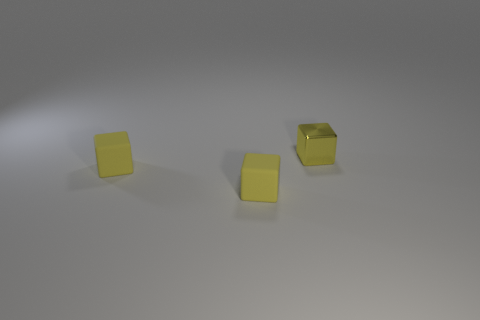Add 3 small yellow rubber things. How many objects exist? 6 Subtract all yellow shiny cubes. Subtract all brown metal cylinders. How many objects are left? 2 Add 3 yellow things. How many yellow things are left? 6 Add 3 tiny cubes. How many tiny cubes exist? 6 Subtract 0 gray cubes. How many objects are left? 3 